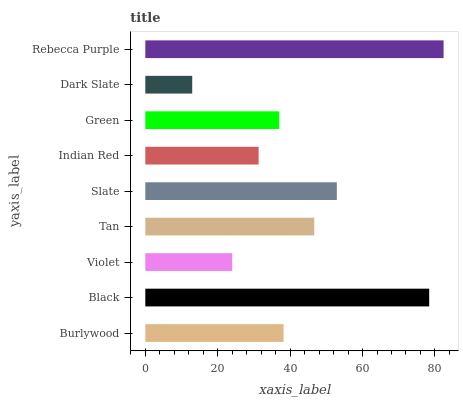Is Dark Slate the minimum?
Answer yes or no. Yes. Is Rebecca Purple the maximum?
Answer yes or no. Yes. Is Black the minimum?
Answer yes or no. No. Is Black the maximum?
Answer yes or no. No. Is Black greater than Burlywood?
Answer yes or no. Yes. Is Burlywood less than Black?
Answer yes or no. Yes. Is Burlywood greater than Black?
Answer yes or no. No. Is Black less than Burlywood?
Answer yes or no. No. Is Burlywood the high median?
Answer yes or no. Yes. Is Burlywood the low median?
Answer yes or no. Yes. Is Violet the high median?
Answer yes or no. No. Is Black the low median?
Answer yes or no. No. 